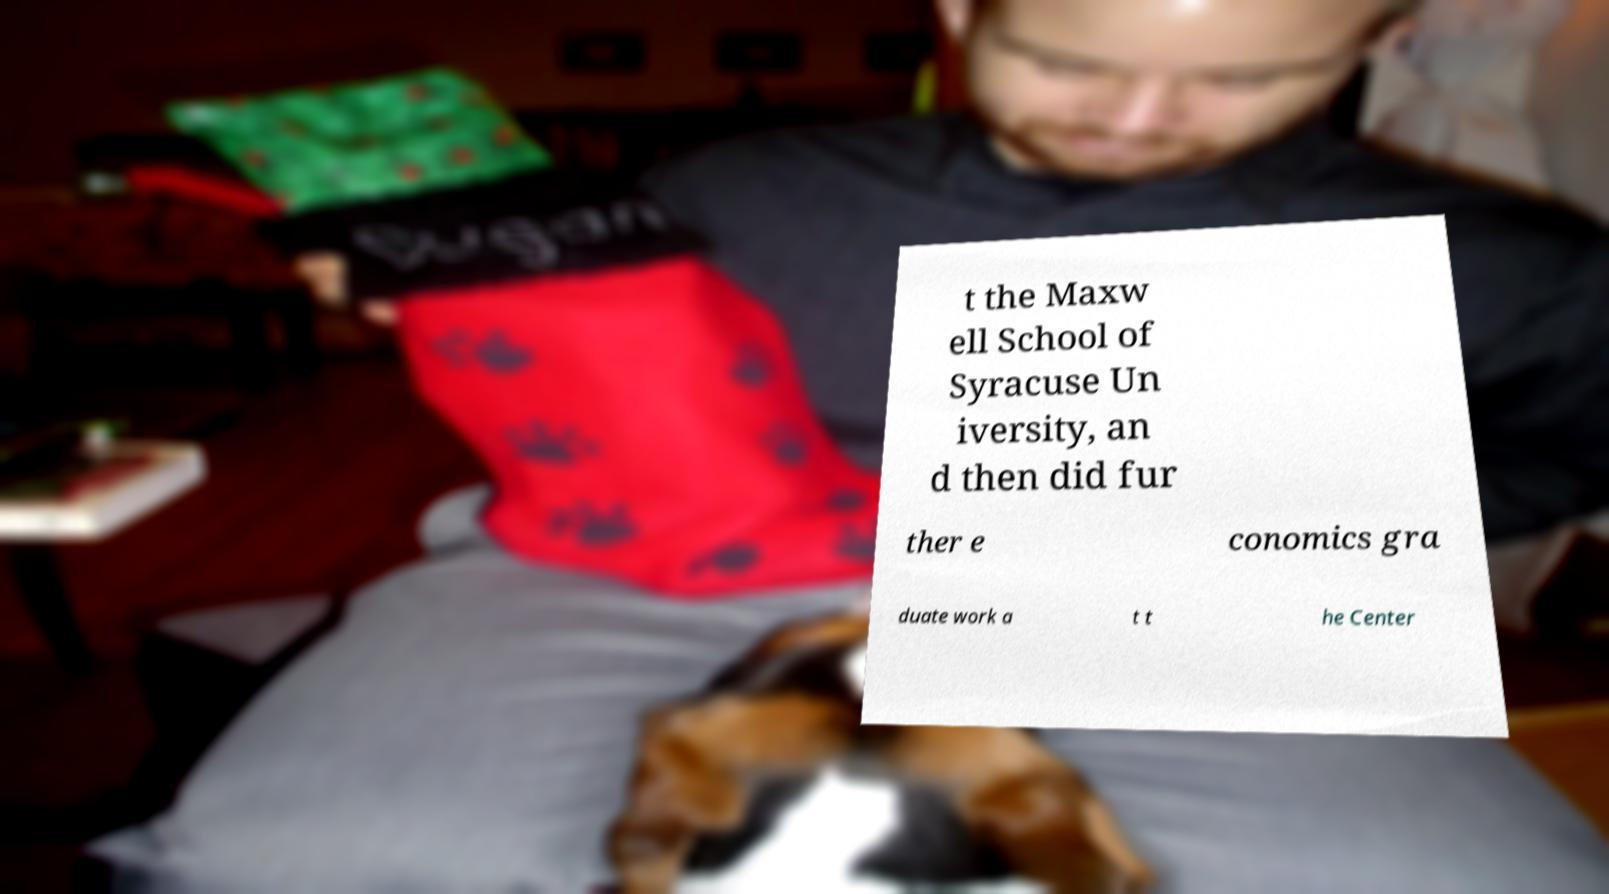Please identify and transcribe the text found in this image. t the Maxw ell School of Syracuse Un iversity, an d then did fur ther e conomics gra duate work a t t he Center 